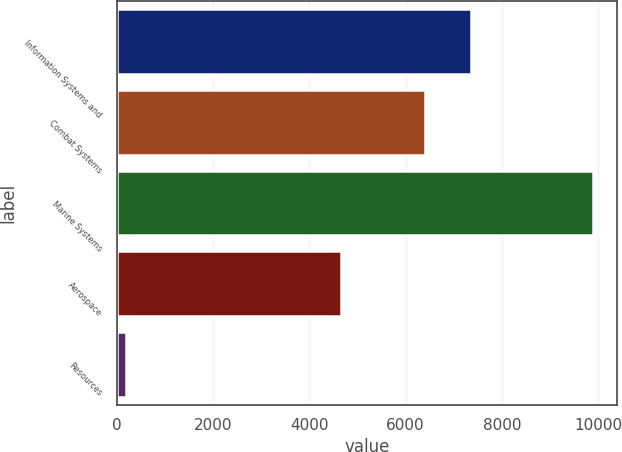Convert chart. <chart><loc_0><loc_0><loc_500><loc_500><bar_chart><fcel>Information Systems and<fcel>Combat Systems<fcel>Marine Systems<fcel>Aerospace<fcel>Resources<nl><fcel>7367.9<fcel>6398<fcel>9899<fcel>4652<fcel>200<nl></chart> 